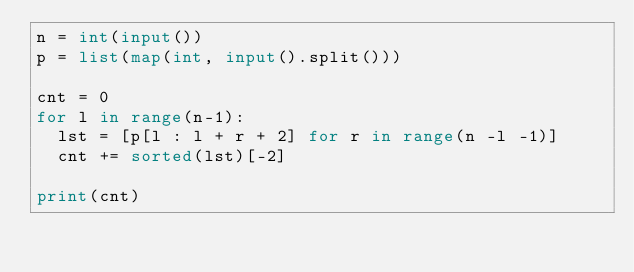Convert code to text. <code><loc_0><loc_0><loc_500><loc_500><_Python_>n = int(input())
p = list(map(int, input().split()))

cnt = 0
for l in range(n-1):
  lst = [p[l : l + r + 2] for r in range(n -l -1)]
  cnt += sorted(lst)[-2]
    
print(cnt)</code> 